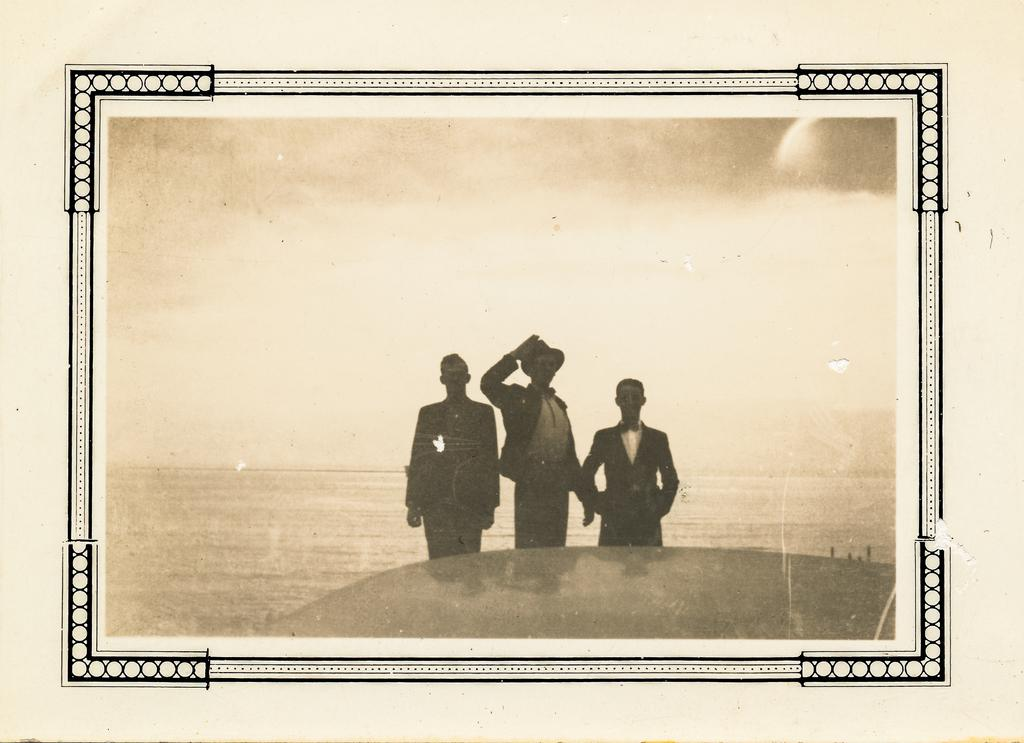What is the main subject of the image? There is a photo in the image. What can be seen in the photo? The photo contains three persons standing. What is visible in the background of the image? The sky is visible in the image. How many roots can be seen growing from the cactus in the image? There is no cactus present in the image, so it is not possible to determine the number of roots. 